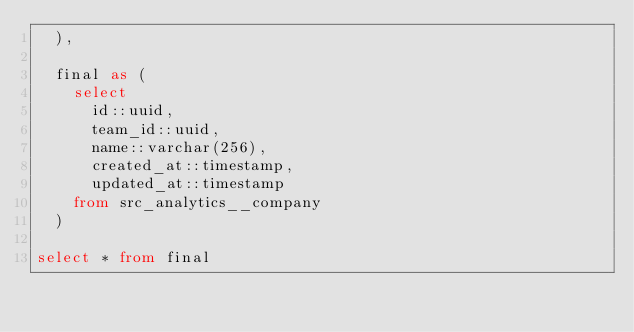<code> <loc_0><loc_0><loc_500><loc_500><_SQL_>  ),

  final as (
    select
      id::uuid,
      team_id::uuid,
      name::varchar(256),
      created_at::timestamp,
      updated_at::timestamp
    from src_analytics__company
  )

select * from final</code> 